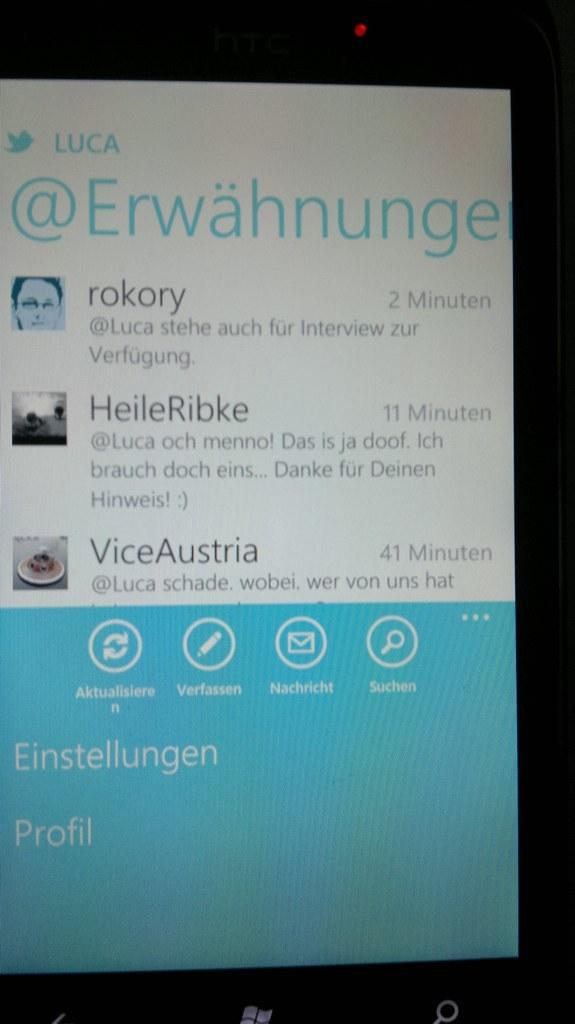<image>
Present a compact description of the photo's key features. Two minutes ago a new Twitter message popped up on the screen. 